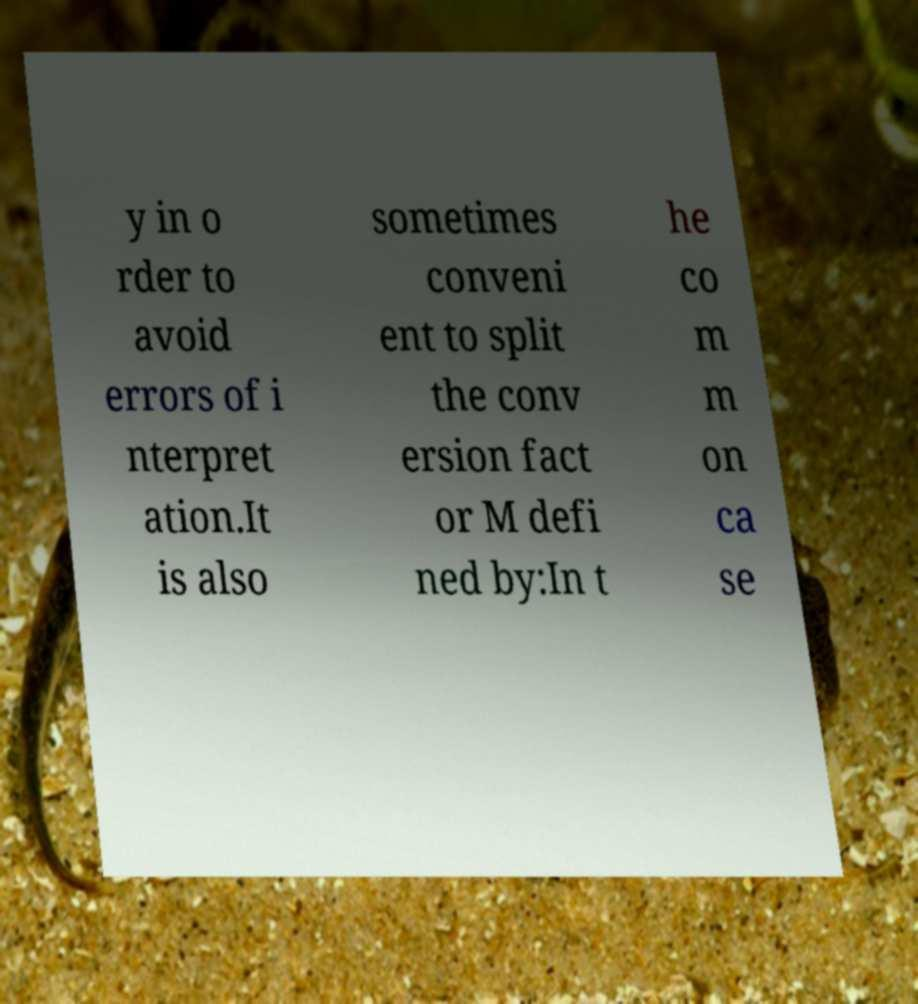Could you assist in decoding the text presented in this image and type it out clearly? y in o rder to avoid errors of i nterpret ation.It is also sometimes conveni ent to split the conv ersion fact or M defi ned by:In t he co m m on ca se 